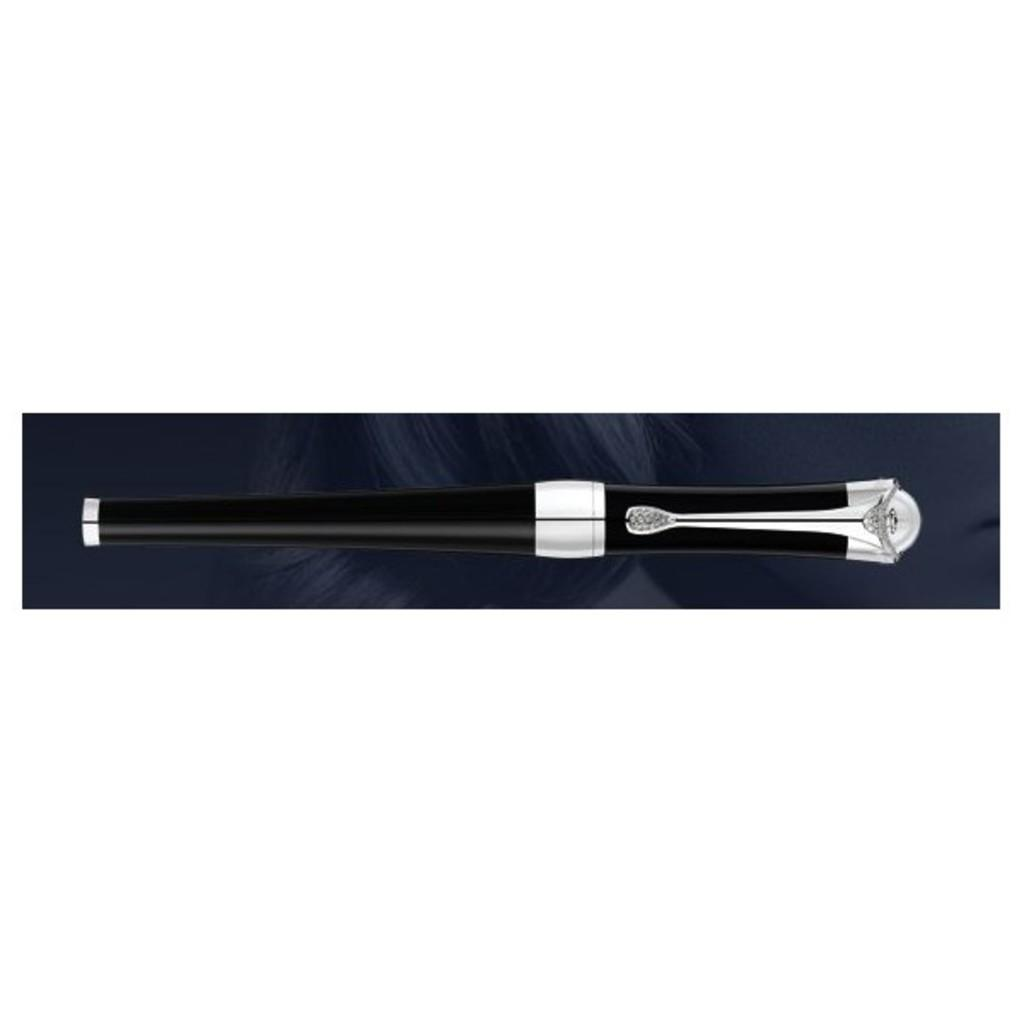What object can be seen in the image? There is a pen in the image. What type of sofa is depicted in the image? There is no sofa present in the image; it only features a pen. 